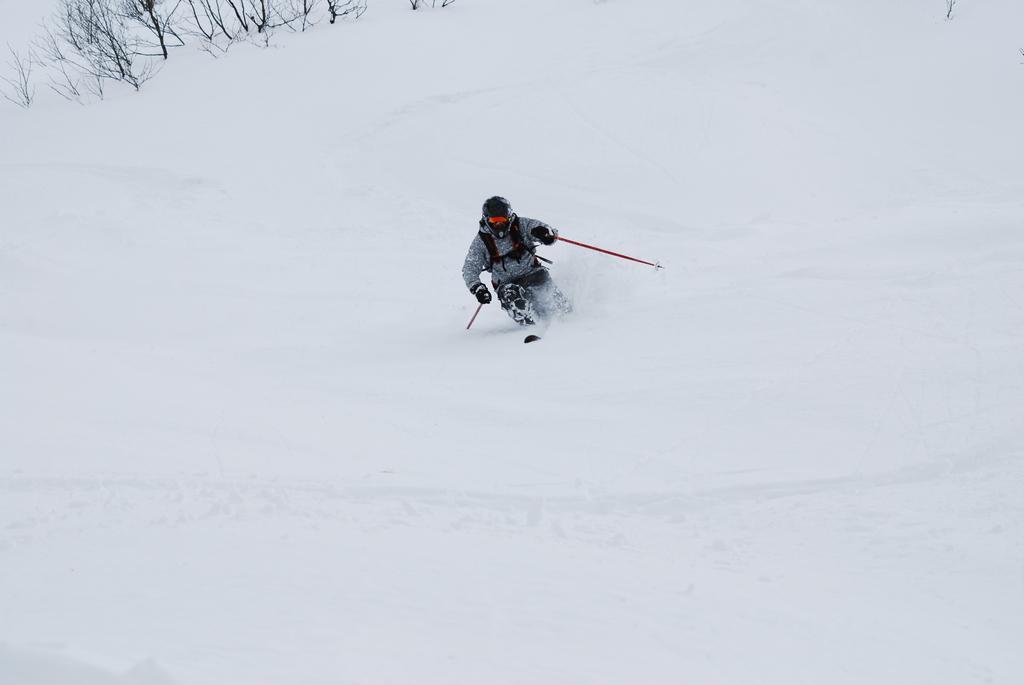Please provide a concise description of this image. In the center of the image there is a person skiing on the snow. In the background there are plants. 